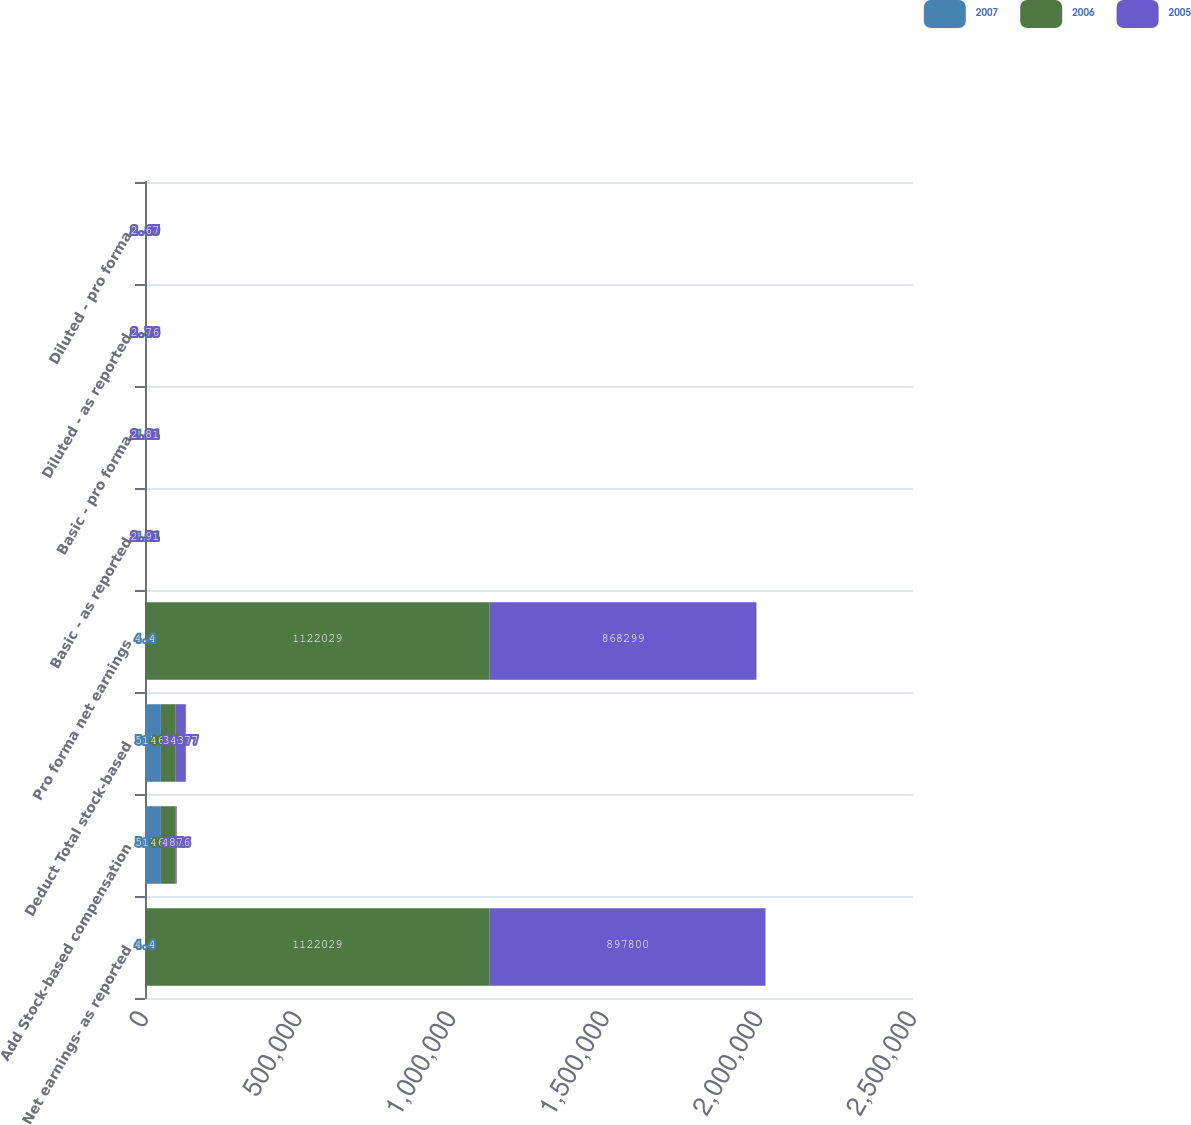Convert chart. <chart><loc_0><loc_0><loc_500><loc_500><stacked_bar_chart><ecel><fcel>Net earnings- as reported<fcel>Add Stock-based compensation<fcel>Deduct Total stock-based<fcel>Pro forma net earnings<fcel>Basic - as reported<fcel>Basic - pro forma<fcel>Diluted - as reported<fcel>Diluted - pro forma<nl><fcel>2007<fcel>4.4<fcel>51546<fcel>51546<fcel>4.4<fcel>4.4<fcel>4.4<fcel>4.19<fcel>4.19<nl><fcel>2006<fcel>1.12203e+06<fcel>46854<fcel>46854<fcel>1.12203e+06<fcel>3.64<fcel>3.64<fcel>3.48<fcel>3.48<nl><fcel>2005<fcel>897800<fcel>4876<fcel>34377<fcel>868299<fcel>2.91<fcel>2.81<fcel>2.76<fcel>2.67<nl></chart> 